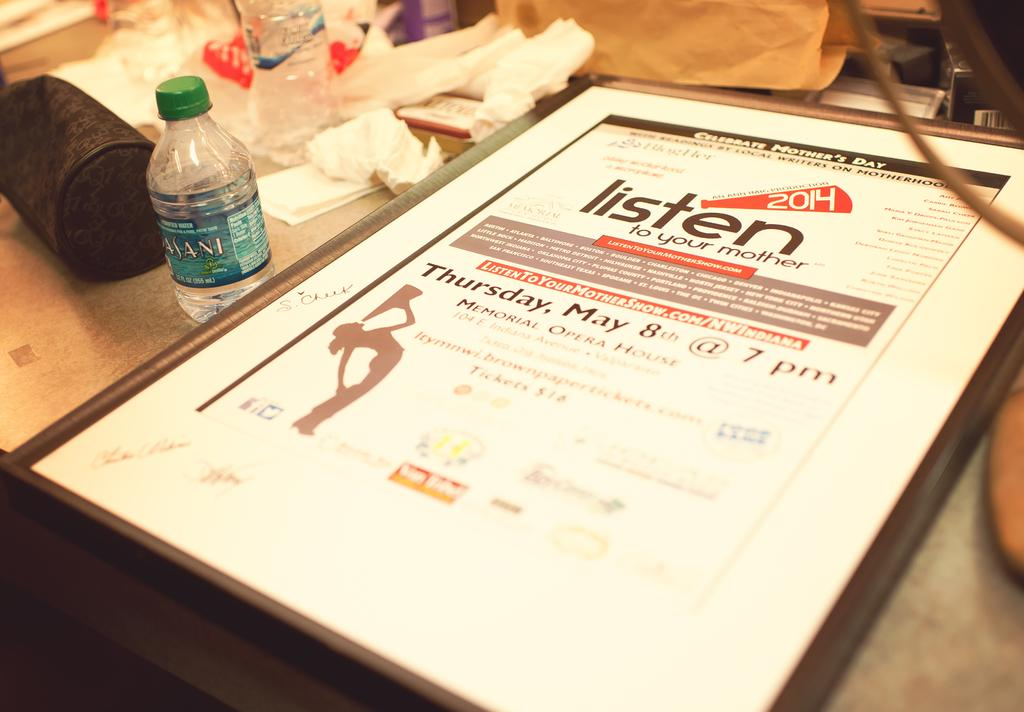What piece of furniture is present in the image? A: There is a table in the image. What is placed on the table? There is an invitation and a water bottle on the table. Are there any other objects on the table? Yes, there are some other objects on the table. What type of underwear is the father wearing in the image? There is no father or underwear present in the image. 